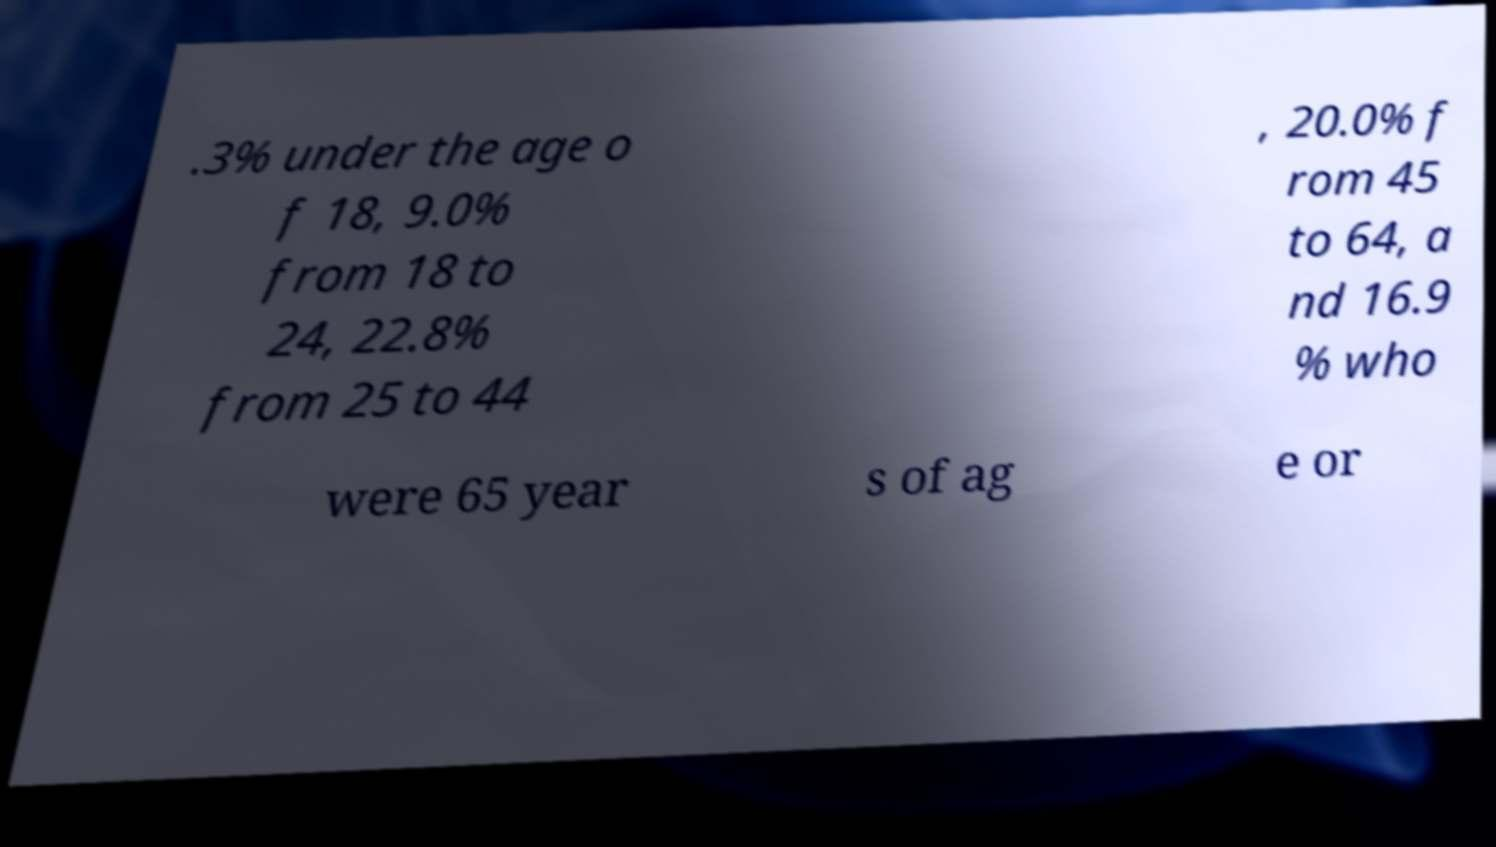Can you read and provide the text displayed in the image?This photo seems to have some interesting text. Can you extract and type it out for me? .3% under the age o f 18, 9.0% from 18 to 24, 22.8% from 25 to 44 , 20.0% f rom 45 to 64, a nd 16.9 % who were 65 year s of ag e or 